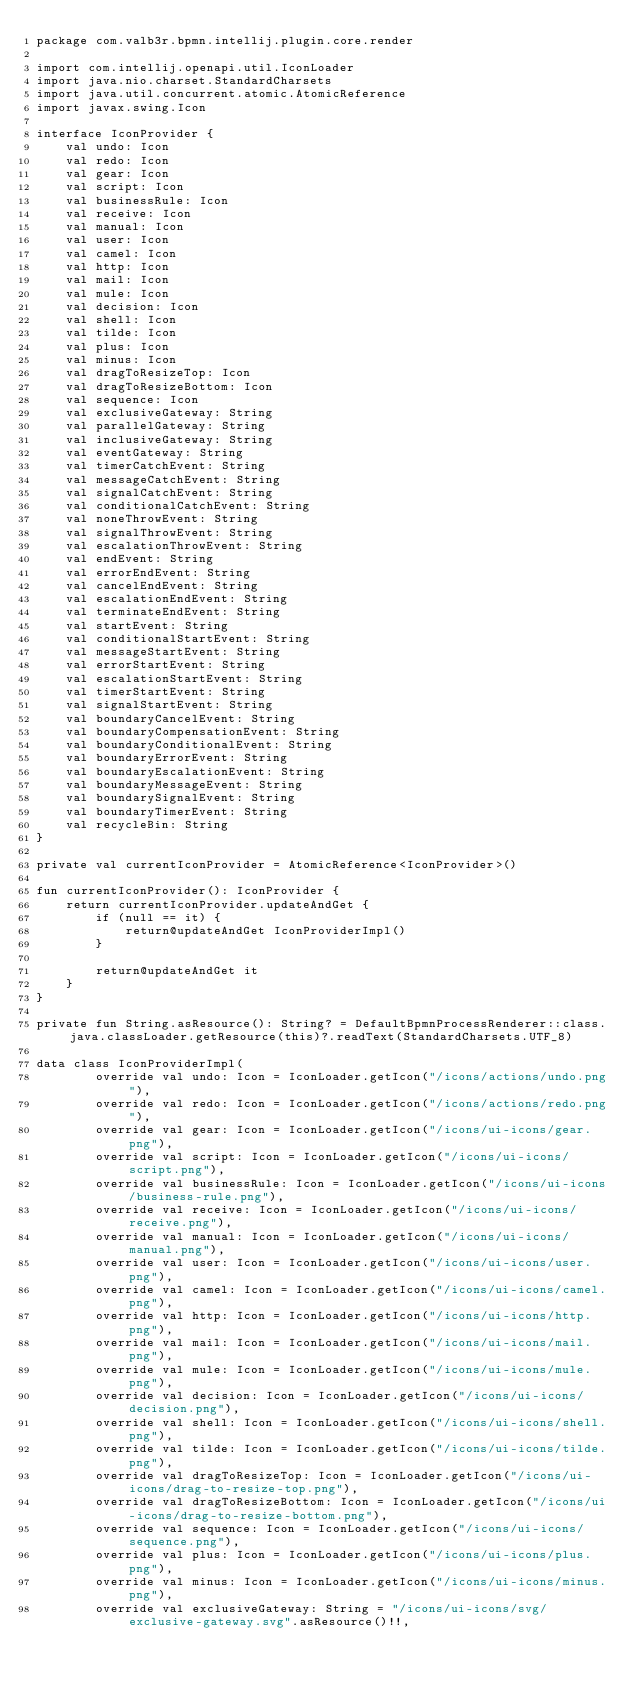<code> <loc_0><loc_0><loc_500><loc_500><_Kotlin_>package com.valb3r.bpmn.intellij.plugin.core.render

import com.intellij.openapi.util.IconLoader
import java.nio.charset.StandardCharsets
import java.util.concurrent.atomic.AtomicReference
import javax.swing.Icon

interface IconProvider {
    val undo: Icon
    val redo: Icon
    val gear: Icon
    val script: Icon
    val businessRule: Icon
    val receive: Icon
    val manual: Icon
    val user: Icon
    val camel: Icon
    val http: Icon
    val mail: Icon
    val mule: Icon
    val decision: Icon
    val shell: Icon
    val tilde: Icon
    val plus: Icon
    val minus: Icon
    val dragToResizeTop: Icon
    val dragToResizeBottom: Icon
    val sequence: Icon
    val exclusiveGateway: String
    val parallelGateway: String
    val inclusiveGateway: String
    val eventGateway: String
    val timerCatchEvent: String
    val messageCatchEvent: String
    val signalCatchEvent: String
    val conditionalCatchEvent: String
    val noneThrowEvent: String
    val signalThrowEvent: String
    val escalationThrowEvent: String
    val endEvent: String
    val errorEndEvent: String
    val cancelEndEvent: String
    val escalationEndEvent: String
    val terminateEndEvent: String
    val startEvent: String
    val conditionalStartEvent: String
    val messageStartEvent: String
    val errorStartEvent: String
    val escalationStartEvent: String
    val timerStartEvent: String
    val signalStartEvent: String
    val boundaryCancelEvent: String
    val boundaryCompensationEvent: String
    val boundaryConditionalEvent: String
    val boundaryErrorEvent: String
    val boundaryEscalationEvent: String
    val boundaryMessageEvent: String
    val boundarySignalEvent: String
    val boundaryTimerEvent: String
    val recycleBin: String
}

private val currentIconProvider = AtomicReference<IconProvider>()

fun currentIconProvider(): IconProvider {
    return currentIconProvider.updateAndGet {
        if (null == it) {
            return@updateAndGet IconProviderImpl()
        }

        return@updateAndGet it
    }
}

private fun String.asResource(): String? = DefaultBpmnProcessRenderer::class.java.classLoader.getResource(this)?.readText(StandardCharsets.UTF_8)

data class IconProviderImpl(
        override val undo: Icon = IconLoader.getIcon("/icons/actions/undo.png"),
        override val redo: Icon = IconLoader.getIcon("/icons/actions/redo.png"),
        override val gear: Icon = IconLoader.getIcon("/icons/ui-icons/gear.png"),
        override val script: Icon = IconLoader.getIcon("/icons/ui-icons/script.png"),
        override val businessRule: Icon = IconLoader.getIcon("/icons/ui-icons/business-rule.png"),
        override val receive: Icon = IconLoader.getIcon("/icons/ui-icons/receive.png"),
        override val manual: Icon = IconLoader.getIcon("/icons/ui-icons/manual.png"),
        override val user: Icon = IconLoader.getIcon("/icons/ui-icons/user.png"),
        override val camel: Icon = IconLoader.getIcon("/icons/ui-icons/camel.png"),
        override val http: Icon = IconLoader.getIcon("/icons/ui-icons/http.png"),
        override val mail: Icon = IconLoader.getIcon("/icons/ui-icons/mail.png"),
        override val mule: Icon = IconLoader.getIcon("/icons/ui-icons/mule.png"),
        override val decision: Icon = IconLoader.getIcon("/icons/ui-icons/decision.png"),
        override val shell: Icon = IconLoader.getIcon("/icons/ui-icons/shell.png"),
        override val tilde: Icon = IconLoader.getIcon("/icons/ui-icons/tilde.png"),
        override val dragToResizeTop: Icon = IconLoader.getIcon("/icons/ui-icons/drag-to-resize-top.png"),
        override val dragToResizeBottom: Icon = IconLoader.getIcon("/icons/ui-icons/drag-to-resize-bottom.png"),
        override val sequence: Icon = IconLoader.getIcon("/icons/ui-icons/sequence.png"),
        override val plus: Icon = IconLoader.getIcon("/icons/ui-icons/plus.png"),
        override val minus: Icon = IconLoader.getIcon("/icons/ui-icons/minus.png"),
        override val exclusiveGateway: String = "/icons/ui-icons/svg/exclusive-gateway.svg".asResource()!!,</code> 